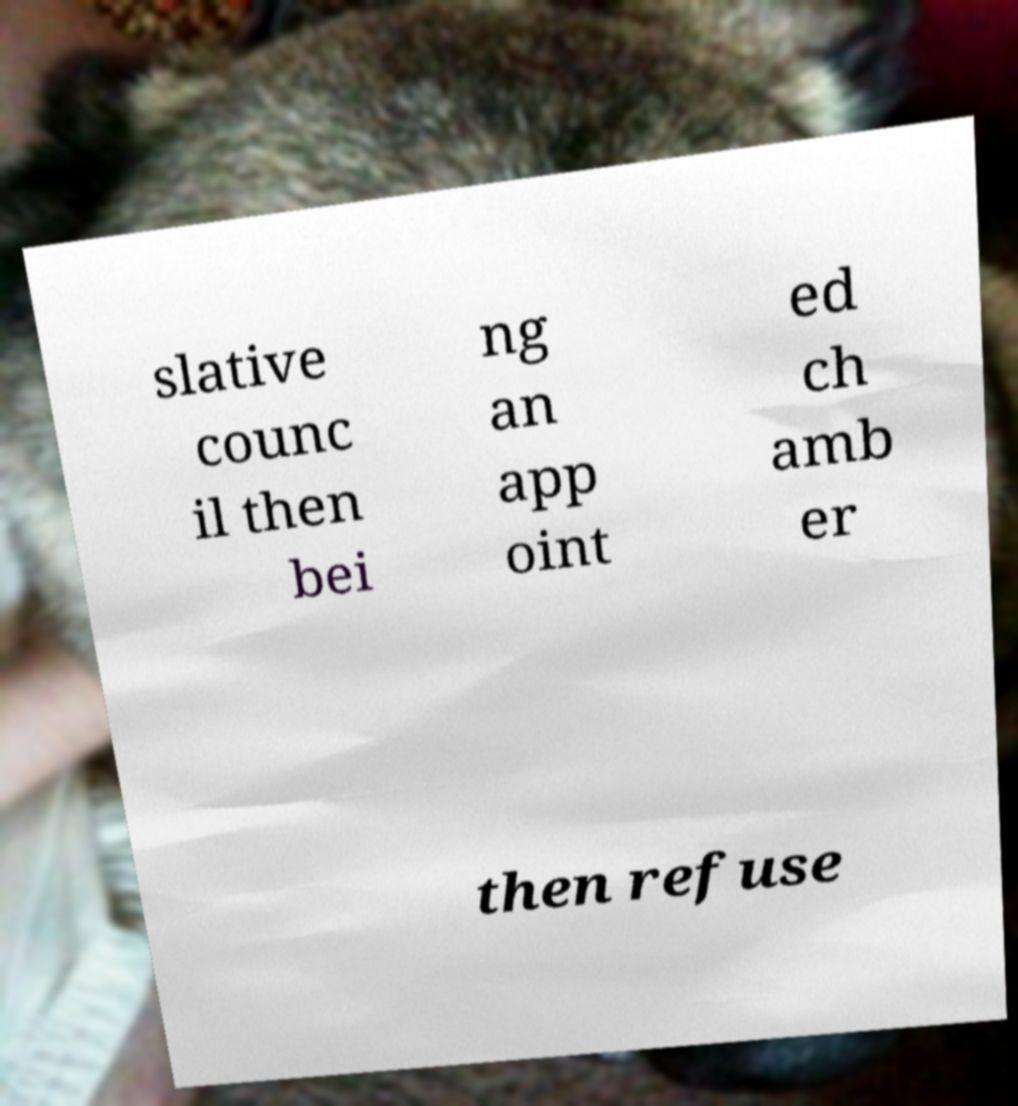Can you read and provide the text displayed in the image?This photo seems to have some interesting text. Can you extract and type it out for me? slative counc il then bei ng an app oint ed ch amb er then refuse 